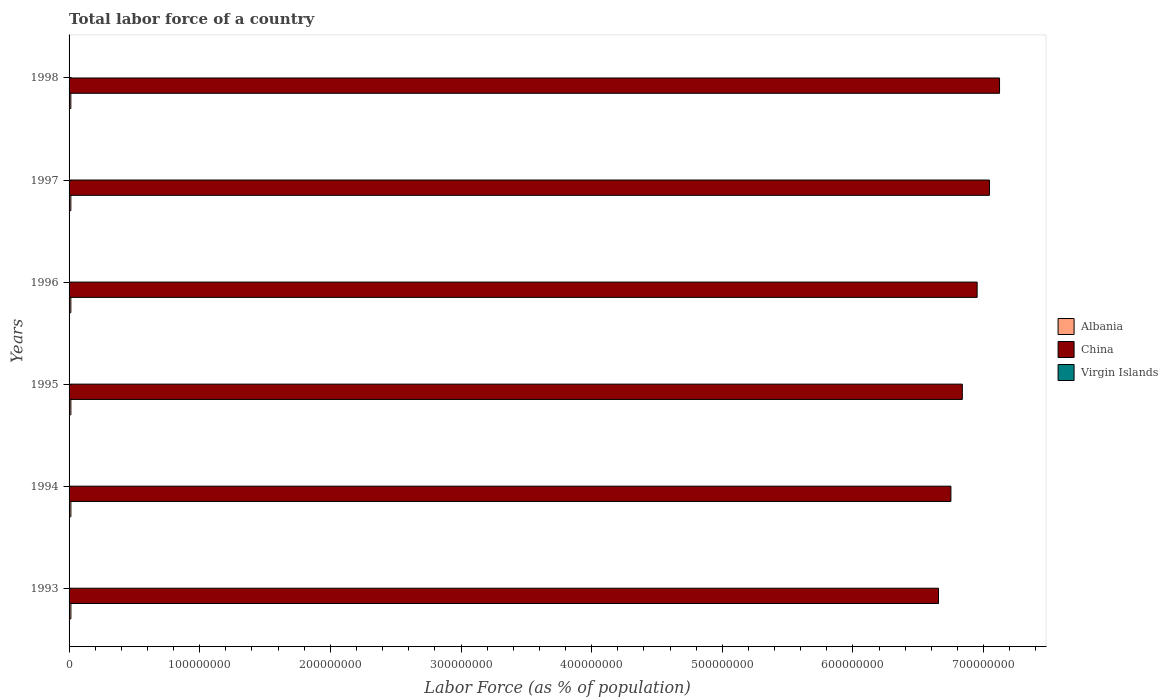How many different coloured bars are there?
Make the answer very short. 3. How many groups of bars are there?
Your answer should be compact. 6. Are the number of bars per tick equal to the number of legend labels?
Give a very brief answer. Yes. How many bars are there on the 5th tick from the top?
Ensure brevity in your answer.  3. In how many cases, is the number of bars for a given year not equal to the number of legend labels?
Your answer should be very brief. 0. What is the percentage of labor force in China in 1995?
Offer a terse response. 6.84e+08. Across all years, what is the maximum percentage of labor force in Albania?
Provide a short and direct response. 1.41e+06. Across all years, what is the minimum percentage of labor force in China?
Provide a succinct answer. 6.65e+08. What is the total percentage of labor force in Virgin Islands in the graph?
Provide a succinct answer. 3.06e+05. What is the difference between the percentage of labor force in China in 1995 and that in 1996?
Provide a short and direct response. -1.13e+07. What is the difference between the percentage of labor force in Virgin Islands in 1996 and the percentage of labor force in China in 1998?
Offer a terse response. -7.12e+08. What is the average percentage of labor force in Albania per year?
Your answer should be very brief. 1.38e+06. In the year 1994, what is the difference between the percentage of labor force in Albania and percentage of labor force in China?
Offer a very short reply. -6.74e+08. What is the ratio of the percentage of labor force in Virgin Islands in 1993 to that in 1996?
Offer a very short reply. 0.99. Is the percentage of labor force in Virgin Islands in 1994 less than that in 1998?
Offer a very short reply. Yes. Is the difference between the percentage of labor force in Albania in 1993 and 1995 greater than the difference between the percentage of labor force in China in 1993 and 1995?
Your response must be concise. Yes. What is the difference between the highest and the second highest percentage of labor force in China?
Ensure brevity in your answer.  7.73e+06. What is the difference between the highest and the lowest percentage of labor force in Albania?
Keep it short and to the point. 4.55e+04. What does the 2nd bar from the top in 1995 represents?
Ensure brevity in your answer.  China. What does the 2nd bar from the bottom in 1994 represents?
Keep it short and to the point. China. How many bars are there?
Keep it short and to the point. 18. How many years are there in the graph?
Offer a terse response. 6. What is the difference between two consecutive major ticks on the X-axis?
Keep it short and to the point. 1.00e+08. Are the values on the major ticks of X-axis written in scientific E-notation?
Offer a very short reply. No. Does the graph contain grids?
Provide a short and direct response. No. Where does the legend appear in the graph?
Offer a very short reply. Center right. How many legend labels are there?
Provide a succinct answer. 3. How are the legend labels stacked?
Ensure brevity in your answer.  Vertical. What is the title of the graph?
Ensure brevity in your answer.  Total labor force of a country. What is the label or title of the X-axis?
Ensure brevity in your answer.  Labor Force (as % of population). What is the Labor Force (as % of population) in Albania in 1993?
Offer a terse response. 1.41e+06. What is the Labor Force (as % of population) in China in 1993?
Provide a short and direct response. 6.65e+08. What is the Labor Force (as % of population) in Virgin Islands in 1993?
Provide a succinct answer. 5.05e+04. What is the Labor Force (as % of population) of Albania in 1994?
Provide a short and direct response. 1.39e+06. What is the Labor Force (as % of population) of China in 1994?
Provide a succinct answer. 6.75e+08. What is the Labor Force (as % of population) in Virgin Islands in 1994?
Give a very brief answer. 5.08e+04. What is the Labor Force (as % of population) of Albania in 1995?
Provide a succinct answer. 1.38e+06. What is the Labor Force (as % of population) of China in 1995?
Offer a very short reply. 6.84e+08. What is the Labor Force (as % of population) of Virgin Islands in 1995?
Keep it short and to the point. 5.12e+04. What is the Labor Force (as % of population) in Albania in 1996?
Your response must be concise. 1.37e+06. What is the Labor Force (as % of population) in China in 1996?
Ensure brevity in your answer.  6.95e+08. What is the Labor Force (as % of population) of Virgin Islands in 1996?
Offer a terse response. 5.11e+04. What is the Labor Force (as % of population) in Albania in 1997?
Make the answer very short. 1.37e+06. What is the Labor Force (as % of population) of China in 1997?
Provide a succinct answer. 7.04e+08. What is the Labor Force (as % of population) of Virgin Islands in 1997?
Give a very brief answer. 5.12e+04. What is the Labor Force (as % of population) in Albania in 1998?
Provide a short and direct response. 1.36e+06. What is the Labor Force (as % of population) in China in 1998?
Keep it short and to the point. 7.12e+08. What is the Labor Force (as % of population) in Virgin Islands in 1998?
Your answer should be very brief. 5.17e+04. Across all years, what is the maximum Labor Force (as % of population) in Albania?
Your response must be concise. 1.41e+06. Across all years, what is the maximum Labor Force (as % of population) of China?
Your answer should be compact. 7.12e+08. Across all years, what is the maximum Labor Force (as % of population) in Virgin Islands?
Provide a short and direct response. 5.17e+04. Across all years, what is the minimum Labor Force (as % of population) of Albania?
Provide a succinct answer. 1.36e+06. Across all years, what is the minimum Labor Force (as % of population) of China?
Make the answer very short. 6.65e+08. Across all years, what is the minimum Labor Force (as % of population) in Virgin Islands?
Keep it short and to the point. 5.05e+04. What is the total Labor Force (as % of population) in Albania in the graph?
Offer a terse response. 8.28e+06. What is the total Labor Force (as % of population) in China in the graph?
Ensure brevity in your answer.  4.14e+09. What is the total Labor Force (as % of population) in Virgin Islands in the graph?
Provide a short and direct response. 3.06e+05. What is the difference between the Labor Force (as % of population) in Albania in 1993 and that in 1994?
Your answer should be compact. 1.12e+04. What is the difference between the Labor Force (as % of population) in China in 1993 and that in 1994?
Your answer should be compact. -9.50e+06. What is the difference between the Labor Force (as % of population) in Virgin Islands in 1993 and that in 1994?
Make the answer very short. -348. What is the difference between the Labor Force (as % of population) in Albania in 1993 and that in 1995?
Keep it short and to the point. 2.90e+04. What is the difference between the Labor Force (as % of population) of China in 1993 and that in 1995?
Your answer should be compact. -1.82e+07. What is the difference between the Labor Force (as % of population) of Virgin Islands in 1993 and that in 1995?
Keep it short and to the point. -697. What is the difference between the Labor Force (as % of population) in Albania in 1993 and that in 1996?
Keep it short and to the point. 3.54e+04. What is the difference between the Labor Force (as % of population) in China in 1993 and that in 1996?
Provide a succinct answer. -2.96e+07. What is the difference between the Labor Force (as % of population) in Virgin Islands in 1993 and that in 1996?
Ensure brevity in your answer.  -585. What is the difference between the Labor Force (as % of population) of Albania in 1993 and that in 1997?
Provide a succinct answer. 3.25e+04. What is the difference between the Labor Force (as % of population) of China in 1993 and that in 1997?
Your answer should be very brief. -3.90e+07. What is the difference between the Labor Force (as % of population) of Virgin Islands in 1993 and that in 1997?
Offer a terse response. -771. What is the difference between the Labor Force (as % of population) in Albania in 1993 and that in 1998?
Offer a very short reply. 4.55e+04. What is the difference between the Labor Force (as % of population) in China in 1993 and that in 1998?
Provide a short and direct response. -4.67e+07. What is the difference between the Labor Force (as % of population) in Virgin Islands in 1993 and that in 1998?
Offer a very short reply. -1210. What is the difference between the Labor Force (as % of population) in Albania in 1994 and that in 1995?
Provide a short and direct response. 1.78e+04. What is the difference between the Labor Force (as % of population) of China in 1994 and that in 1995?
Your response must be concise. -8.73e+06. What is the difference between the Labor Force (as % of population) of Virgin Islands in 1994 and that in 1995?
Make the answer very short. -349. What is the difference between the Labor Force (as % of population) of Albania in 1994 and that in 1996?
Provide a short and direct response. 2.42e+04. What is the difference between the Labor Force (as % of population) of China in 1994 and that in 1996?
Your response must be concise. -2.01e+07. What is the difference between the Labor Force (as % of population) of Virgin Islands in 1994 and that in 1996?
Make the answer very short. -237. What is the difference between the Labor Force (as % of population) of Albania in 1994 and that in 1997?
Make the answer very short. 2.13e+04. What is the difference between the Labor Force (as % of population) of China in 1994 and that in 1997?
Your answer should be compact. -2.95e+07. What is the difference between the Labor Force (as % of population) in Virgin Islands in 1994 and that in 1997?
Your answer should be compact. -423. What is the difference between the Labor Force (as % of population) of Albania in 1994 and that in 1998?
Offer a very short reply. 3.43e+04. What is the difference between the Labor Force (as % of population) in China in 1994 and that in 1998?
Give a very brief answer. -3.72e+07. What is the difference between the Labor Force (as % of population) in Virgin Islands in 1994 and that in 1998?
Provide a succinct answer. -862. What is the difference between the Labor Force (as % of population) in Albania in 1995 and that in 1996?
Offer a terse response. 6427. What is the difference between the Labor Force (as % of population) of China in 1995 and that in 1996?
Keep it short and to the point. -1.13e+07. What is the difference between the Labor Force (as % of population) in Virgin Islands in 1995 and that in 1996?
Give a very brief answer. 112. What is the difference between the Labor Force (as % of population) in Albania in 1995 and that in 1997?
Your answer should be very brief. 3514. What is the difference between the Labor Force (as % of population) in China in 1995 and that in 1997?
Provide a short and direct response. -2.08e+07. What is the difference between the Labor Force (as % of population) in Virgin Islands in 1995 and that in 1997?
Offer a terse response. -74. What is the difference between the Labor Force (as % of population) of Albania in 1995 and that in 1998?
Your answer should be very brief. 1.65e+04. What is the difference between the Labor Force (as % of population) in China in 1995 and that in 1998?
Provide a short and direct response. -2.85e+07. What is the difference between the Labor Force (as % of population) in Virgin Islands in 1995 and that in 1998?
Keep it short and to the point. -513. What is the difference between the Labor Force (as % of population) of Albania in 1996 and that in 1997?
Offer a very short reply. -2913. What is the difference between the Labor Force (as % of population) of China in 1996 and that in 1997?
Keep it short and to the point. -9.41e+06. What is the difference between the Labor Force (as % of population) of Virgin Islands in 1996 and that in 1997?
Ensure brevity in your answer.  -186. What is the difference between the Labor Force (as % of population) of Albania in 1996 and that in 1998?
Make the answer very short. 1.01e+04. What is the difference between the Labor Force (as % of population) in China in 1996 and that in 1998?
Ensure brevity in your answer.  -1.71e+07. What is the difference between the Labor Force (as % of population) in Virgin Islands in 1996 and that in 1998?
Provide a short and direct response. -625. What is the difference between the Labor Force (as % of population) of Albania in 1997 and that in 1998?
Ensure brevity in your answer.  1.30e+04. What is the difference between the Labor Force (as % of population) in China in 1997 and that in 1998?
Your answer should be compact. -7.73e+06. What is the difference between the Labor Force (as % of population) in Virgin Islands in 1997 and that in 1998?
Make the answer very short. -439. What is the difference between the Labor Force (as % of population) in Albania in 1993 and the Labor Force (as % of population) in China in 1994?
Your response must be concise. -6.74e+08. What is the difference between the Labor Force (as % of population) of Albania in 1993 and the Labor Force (as % of population) of Virgin Islands in 1994?
Provide a succinct answer. 1.35e+06. What is the difference between the Labor Force (as % of population) of China in 1993 and the Labor Force (as % of population) of Virgin Islands in 1994?
Offer a terse response. 6.65e+08. What is the difference between the Labor Force (as % of population) in Albania in 1993 and the Labor Force (as % of population) in China in 1995?
Give a very brief answer. -6.82e+08. What is the difference between the Labor Force (as % of population) of Albania in 1993 and the Labor Force (as % of population) of Virgin Islands in 1995?
Give a very brief answer. 1.35e+06. What is the difference between the Labor Force (as % of population) of China in 1993 and the Labor Force (as % of population) of Virgin Islands in 1995?
Your response must be concise. 6.65e+08. What is the difference between the Labor Force (as % of population) of Albania in 1993 and the Labor Force (as % of population) of China in 1996?
Provide a succinct answer. -6.94e+08. What is the difference between the Labor Force (as % of population) in Albania in 1993 and the Labor Force (as % of population) in Virgin Islands in 1996?
Keep it short and to the point. 1.35e+06. What is the difference between the Labor Force (as % of population) of China in 1993 and the Labor Force (as % of population) of Virgin Islands in 1996?
Offer a very short reply. 6.65e+08. What is the difference between the Labor Force (as % of population) in Albania in 1993 and the Labor Force (as % of population) in China in 1997?
Your answer should be very brief. -7.03e+08. What is the difference between the Labor Force (as % of population) of Albania in 1993 and the Labor Force (as % of population) of Virgin Islands in 1997?
Your answer should be very brief. 1.35e+06. What is the difference between the Labor Force (as % of population) of China in 1993 and the Labor Force (as % of population) of Virgin Islands in 1997?
Provide a short and direct response. 6.65e+08. What is the difference between the Labor Force (as % of population) of Albania in 1993 and the Labor Force (as % of population) of China in 1998?
Ensure brevity in your answer.  -7.11e+08. What is the difference between the Labor Force (as % of population) of Albania in 1993 and the Labor Force (as % of population) of Virgin Islands in 1998?
Provide a short and direct response. 1.35e+06. What is the difference between the Labor Force (as % of population) of China in 1993 and the Labor Force (as % of population) of Virgin Islands in 1998?
Keep it short and to the point. 6.65e+08. What is the difference between the Labor Force (as % of population) in Albania in 1994 and the Labor Force (as % of population) in China in 1995?
Your answer should be very brief. -6.82e+08. What is the difference between the Labor Force (as % of population) of Albania in 1994 and the Labor Force (as % of population) of Virgin Islands in 1995?
Offer a terse response. 1.34e+06. What is the difference between the Labor Force (as % of population) in China in 1994 and the Labor Force (as % of population) in Virgin Islands in 1995?
Give a very brief answer. 6.75e+08. What is the difference between the Labor Force (as % of population) in Albania in 1994 and the Labor Force (as % of population) in China in 1996?
Offer a terse response. -6.94e+08. What is the difference between the Labor Force (as % of population) in Albania in 1994 and the Labor Force (as % of population) in Virgin Islands in 1996?
Give a very brief answer. 1.34e+06. What is the difference between the Labor Force (as % of population) in China in 1994 and the Labor Force (as % of population) in Virgin Islands in 1996?
Provide a succinct answer. 6.75e+08. What is the difference between the Labor Force (as % of population) of Albania in 1994 and the Labor Force (as % of population) of China in 1997?
Your response must be concise. -7.03e+08. What is the difference between the Labor Force (as % of population) of Albania in 1994 and the Labor Force (as % of population) of Virgin Islands in 1997?
Your answer should be compact. 1.34e+06. What is the difference between the Labor Force (as % of population) in China in 1994 and the Labor Force (as % of population) in Virgin Islands in 1997?
Give a very brief answer. 6.75e+08. What is the difference between the Labor Force (as % of population) of Albania in 1994 and the Labor Force (as % of population) of China in 1998?
Offer a very short reply. -7.11e+08. What is the difference between the Labor Force (as % of population) in Albania in 1994 and the Labor Force (as % of population) in Virgin Islands in 1998?
Your answer should be compact. 1.34e+06. What is the difference between the Labor Force (as % of population) of China in 1994 and the Labor Force (as % of population) of Virgin Islands in 1998?
Provide a short and direct response. 6.75e+08. What is the difference between the Labor Force (as % of population) of Albania in 1995 and the Labor Force (as % of population) of China in 1996?
Provide a short and direct response. -6.94e+08. What is the difference between the Labor Force (as % of population) of Albania in 1995 and the Labor Force (as % of population) of Virgin Islands in 1996?
Ensure brevity in your answer.  1.33e+06. What is the difference between the Labor Force (as % of population) in China in 1995 and the Labor Force (as % of population) in Virgin Islands in 1996?
Keep it short and to the point. 6.84e+08. What is the difference between the Labor Force (as % of population) in Albania in 1995 and the Labor Force (as % of population) in China in 1997?
Give a very brief answer. -7.03e+08. What is the difference between the Labor Force (as % of population) in Albania in 1995 and the Labor Force (as % of population) in Virgin Islands in 1997?
Your response must be concise. 1.32e+06. What is the difference between the Labor Force (as % of population) in China in 1995 and the Labor Force (as % of population) in Virgin Islands in 1997?
Make the answer very short. 6.84e+08. What is the difference between the Labor Force (as % of population) in Albania in 1995 and the Labor Force (as % of population) in China in 1998?
Ensure brevity in your answer.  -7.11e+08. What is the difference between the Labor Force (as % of population) of Albania in 1995 and the Labor Force (as % of population) of Virgin Islands in 1998?
Your answer should be very brief. 1.32e+06. What is the difference between the Labor Force (as % of population) in China in 1995 and the Labor Force (as % of population) in Virgin Islands in 1998?
Make the answer very short. 6.84e+08. What is the difference between the Labor Force (as % of population) in Albania in 1996 and the Labor Force (as % of population) in China in 1997?
Give a very brief answer. -7.03e+08. What is the difference between the Labor Force (as % of population) of Albania in 1996 and the Labor Force (as % of population) of Virgin Islands in 1997?
Keep it short and to the point. 1.32e+06. What is the difference between the Labor Force (as % of population) in China in 1996 and the Labor Force (as % of population) in Virgin Islands in 1997?
Provide a short and direct response. 6.95e+08. What is the difference between the Labor Force (as % of population) of Albania in 1996 and the Labor Force (as % of population) of China in 1998?
Your answer should be compact. -7.11e+08. What is the difference between the Labor Force (as % of population) of Albania in 1996 and the Labor Force (as % of population) of Virgin Islands in 1998?
Give a very brief answer. 1.32e+06. What is the difference between the Labor Force (as % of population) in China in 1996 and the Labor Force (as % of population) in Virgin Islands in 1998?
Your answer should be very brief. 6.95e+08. What is the difference between the Labor Force (as % of population) in Albania in 1997 and the Labor Force (as % of population) in China in 1998?
Provide a succinct answer. -7.11e+08. What is the difference between the Labor Force (as % of population) of Albania in 1997 and the Labor Force (as % of population) of Virgin Islands in 1998?
Ensure brevity in your answer.  1.32e+06. What is the difference between the Labor Force (as % of population) of China in 1997 and the Labor Force (as % of population) of Virgin Islands in 1998?
Your answer should be very brief. 7.04e+08. What is the average Labor Force (as % of population) of Albania per year?
Your response must be concise. 1.38e+06. What is the average Labor Force (as % of population) of China per year?
Provide a short and direct response. 6.89e+08. What is the average Labor Force (as % of population) in Virgin Islands per year?
Offer a very short reply. 5.11e+04. In the year 1993, what is the difference between the Labor Force (as % of population) in Albania and Labor Force (as % of population) in China?
Your answer should be compact. -6.64e+08. In the year 1993, what is the difference between the Labor Force (as % of population) in Albania and Labor Force (as % of population) in Virgin Islands?
Provide a succinct answer. 1.35e+06. In the year 1993, what is the difference between the Labor Force (as % of population) of China and Labor Force (as % of population) of Virgin Islands?
Keep it short and to the point. 6.65e+08. In the year 1994, what is the difference between the Labor Force (as % of population) in Albania and Labor Force (as % of population) in China?
Your answer should be compact. -6.74e+08. In the year 1994, what is the difference between the Labor Force (as % of population) in Albania and Labor Force (as % of population) in Virgin Islands?
Offer a very short reply. 1.34e+06. In the year 1994, what is the difference between the Labor Force (as % of population) of China and Labor Force (as % of population) of Virgin Islands?
Give a very brief answer. 6.75e+08. In the year 1995, what is the difference between the Labor Force (as % of population) in Albania and Labor Force (as % of population) in China?
Offer a terse response. -6.82e+08. In the year 1995, what is the difference between the Labor Force (as % of population) of Albania and Labor Force (as % of population) of Virgin Islands?
Your response must be concise. 1.32e+06. In the year 1995, what is the difference between the Labor Force (as % of population) in China and Labor Force (as % of population) in Virgin Islands?
Keep it short and to the point. 6.84e+08. In the year 1996, what is the difference between the Labor Force (as % of population) in Albania and Labor Force (as % of population) in China?
Make the answer very short. -6.94e+08. In the year 1996, what is the difference between the Labor Force (as % of population) in Albania and Labor Force (as % of population) in Virgin Islands?
Make the answer very short. 1.32e+06. In the year 1996, what is the difference between the Labor Force (as % of population) in China and Labor Force (as % of population) in Virgin Islands?
Offer a terse response. 6.95e+08. In the year 1997, what is the difference between the Labor Force (as % of population) in Albania and Labor Force (as % of population) in China?
Make the answer very short. -7.03e+08. In the year 1997, what is the difference between the Labor Force (as % of population) of Albania and Labor Force (as % of population) of Virgin Islands?
Provide a succinct answer. 1.32e+06. In the year 1997, what is the difference between the Labor Force (as % of population) in China and Labor Force (as % of population) in Virgin Islands?
Keep it short and to the point. 7.04e+08. In the year 1998, what is the difference between the Labor Force (as % of population) of Albania and Labor Force (as % of population) of China?
Your response must be concise. -7.11e+08. In the year 1998, what is the difference between the Labor Force (as % of population) of Albania and Labor Force (as % of population) of Virgin Islands?
Provide a short and direct response. 1.31e+06. In the year 1998, what is the difference between the Labor Force (as % of population) of China and Labor Force (as % of population) of Virgin Islands?
Ensure brevity in your answer.  7.12e+08. What is the ratio of the Labor Force (as % of population) in China in 1993 to that in 1994?
Ensure brevity in your answer.  0.99. What is the ratio of the Labor Force (as % of population) in China in 1993 to that in 1995?
Make the answer very short. 0.97. What is the ratio of the Labor Force (as % of population) in Virgin Islands in 1993 to that in 1995?
Ensure brevity in your answer.  0.99. What is the ratio of the Labor Force (as % of population) in Albania in 1993 to that in 1996?
Ensure brevity in your answer.  1.03. What is the ratio of the Labor Force (as % of population) in China in 1993 to that in 1996?
Offer a terse response. 0.96. What is the ratio of the Labor Force (as % of population) in Albania in 1993 to that in 1997?
Keep it short and to the point. 1.02. What is the ratio of the Labor Force (as % of population) in China in 1993 to that in 1997?
Your response must be concise. 0.94. What is the ratio of the Labor Force (as % of population) of Albania in 1993 to that in 1998?
Offer a very short reply. 1.03. What is the ratio of the Labor Force (as % of population) of China in 1993 to that in 1998?
Provide a short and direct response. 0.93. What is the ratio of the Labor Force (as % of population) of Virgin Islands in 1993 to that in 1998?
Your answer should be compact. 0.98. What is the ratio of the Labor Force (as % of population) in Albania in 1994 to that in 1995?
Offer a terse response. 1.01. What is the ratio of the Labor Force (as % of population) in China in 1994 to that in 1995?
Make the answer very short. 0.99. What is the ratio of the Labor Force (as % of population) of Virgin Islands in 1994 to that in 1995?
Ensure brevity in your answer.  0.99. What is the ratio of the Labor Force (as % of population) of Albania in 1994 to that in 1996?
Your answer should be compact. 1.02. What is the ratio of the Labor Force (as % of population) of China in 1994 to that in 1996?
Ensure brevity in your answer.  0.97. What is the ratio of the Labor Force (as % of population) in Virgin Islands in 1994 to that in 1996?
Your answer should be very brief. 1. What is the ratio of the Labor Force (as % of population) of Albania in 1994 to that in 1997?
Offer a terse response. 1.02. What is the ratio of the Labor Force (as % of population) of China in 1994 to that in 1997?
Your response must be concise. 0.96. What is the ratio of the Labor Force (as % of population) in Albania in 1994 to that in 1998?
Your answer should be compact. 1.03. What is the ratio of the Labor Force (as % of population) of China in 1994 to that in 1998?
Offer a terse response. 0.95. What is the ratio of the Labor Force (as % of population) in Virgin Islands in 1994 to that in 1998?
Provide a short and direct response. 0.98. What is the ratio of the Labor Force (as % of population) of China in 1995 to that in 1996?
Offer a very short reply. 0.98. What is the ratio of the Labor Force (as % of population) in China in 1995 to that in 1997?
Provide a short and direct response. 0.97. What is the ratio of the Labor Force (as % of population) in Virgin Islands in 1995 to that in 1997?
Your response must be concise. 1. What is the ratio of the Labor Force (as % of population) in Albania in 1995 to that in 1998?
Your response must be concise. 1.01. What is the ratio of the Labor Force (as % of population) in Virgin Islands in 1995 to that in 1998?
Make the answer very short. 0.99. What is the ratio of the Labor Force (as % of population) in Albania in 1996 to that in 1997?
Provide a succinct answer. 1. What is the ratio of the Labor Force (as % of population) in China in 1996 to that in 1997?
Ensure brevity in your answer.  0.99. What is the ratio of the Labor Force (as % of population) in Virgin Islands in 1996 to that in 1997?
Give a very brief answer. 1. What is the ratio of the Labor Force (as % of population) in Albania in 1996 to that in 1998?
Your answer should be compact. 1.01. What is the ratio of the Labor Force (as % of population) in China in 1996 to that in 1998?
Your answer should be compact. 0.98. What is the ratio of the Labor Force (as % of population) of Virgin Islands in 1996 to that in 1998?
Provide a short and direct response. 0.99. What is the ratio of the Labor Force (as % of population) in Albania in 1997 to that in 1998?
Offer a terse response. 1.01. What is the ratio of the Labor Force (as % of population) of China in 1997 to that in 1998?
Your response must be concise. 0.99. What is the ratio of the Labor Force (as % of population) of Virgin Islands in 1997 to that in 1998?
Offer a terse response. 0.99. What is the difference between the highest and the second highest Labor Force (as % of population) in Albania?
Your answer should be compact. 1.12e+04. What is the difference between the highest and the second highest Labor Force (as % of population) in China?
Provide a short and direct response. 7.73e+06. What is the difference between the highest and the second highest Labor Force (as % of population) of Virgin Islands?
Provide a short and direct response. 439. What is the difference between the highest and the lowest Labor Force (as % of population) in Albania?
Offer a very short reply. 4.55e+04. What is the difference between the highest and the lowest Labor Force (as % of population) in China?
Make the answer very short. 4.67e+07. What is the difference between the highest and the lowest Labor Force (as % of population) in Virgin Islands?
Your response must be concise. 1210. 